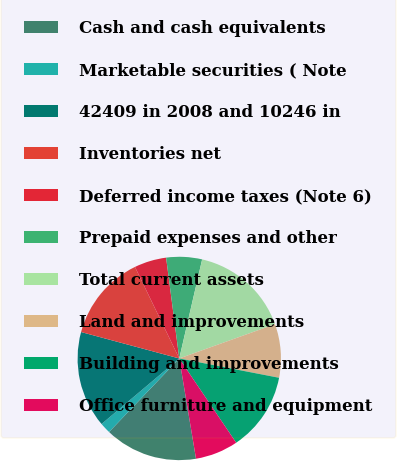<chart> <loc_0><loc_0><loc_500><loc_500><pie_chart><fcel>Cash and cash equivalents<fcel>Marketable securities ( Note<fcel>42409 in 2008 and 10246 in<fcel>Inventories net<fcel>Deferred income taxes (Note 6)<fcel>Prepaid expenses and other<fcel>Total current assets<fcel>Land and improvements<fcel>Building and improvements<fcel>Office furniture and equipment<nl><fcel>14.77%<fcel>1.71%<fcel>15.34%<fcel>13.64%<fcel>5.11%<fcel>5.68%<fcel>15.91%<fcel>8.52%<fcel>12.5%<fcel>6.82%<nl></chart> 